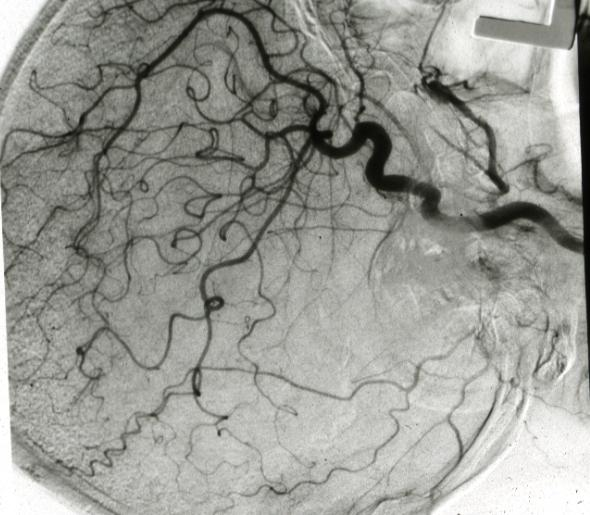does this image show x-ray left side angiogram?
Answer the question using a single word or phrase. Yes 